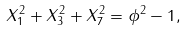<formula> <loc_0><loc_0><loc_500><loc_500>X _ { 1 } ^ { 2 } + X _ { 3 } ^ { 2 } + X _ { 7 } ^ { 2 } = \phi ^ { 2 } - 1 ,</formula> 